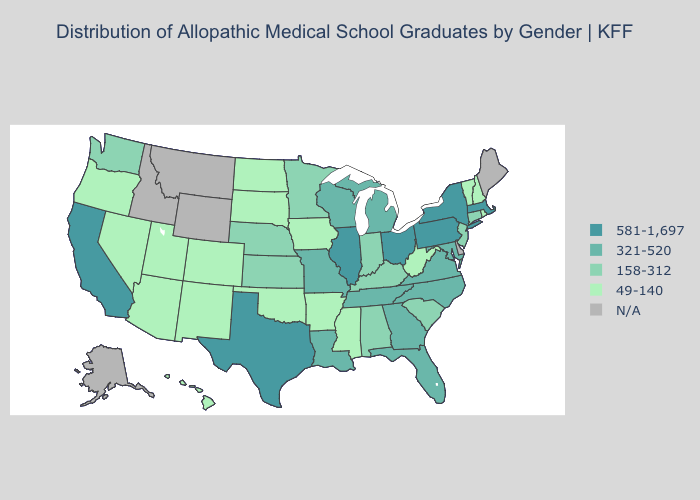Does the map have missing data?
Short answer required. Yes. Does Oklahoma have the lowest value in the South?
Short answer required. Yes. What is the highest value in states that border Kansas?
Answer briefly. 321-520. What is the lowest value in the West?
Concise answer only. 49-140. Among the states that border Vermont , does New Hampshire have the highest value?
Be succinct. No. Does the map have missing data?
Keep it brief. Yes. Is the legend a continuous bar?
Answer briefly. No. Name the states that have a value in the range 581-1,697?
Quick response, please. California, Illinois, Massachusetts, New York, Ohio, Pennsylvania, Texas. Does the map have missing data?
Answer briefly. Yes. Does the map have missing data?
Concise answer only. Yes. Name the states that have a value in the range 581-1,697?
Quick response, please. California, Illinois, Massachusetts, New York, Ohio, Pennsylvania, Texas. What is the value of Maryland?
Be succinct. 321-520. Name the states that have a value in the range N/A?
Concise answer only. Alaska, Delaware, Idaho, Maine, Montana, Wyoming. What is the value of West Virginia?
Answer briefly. 49-140. 